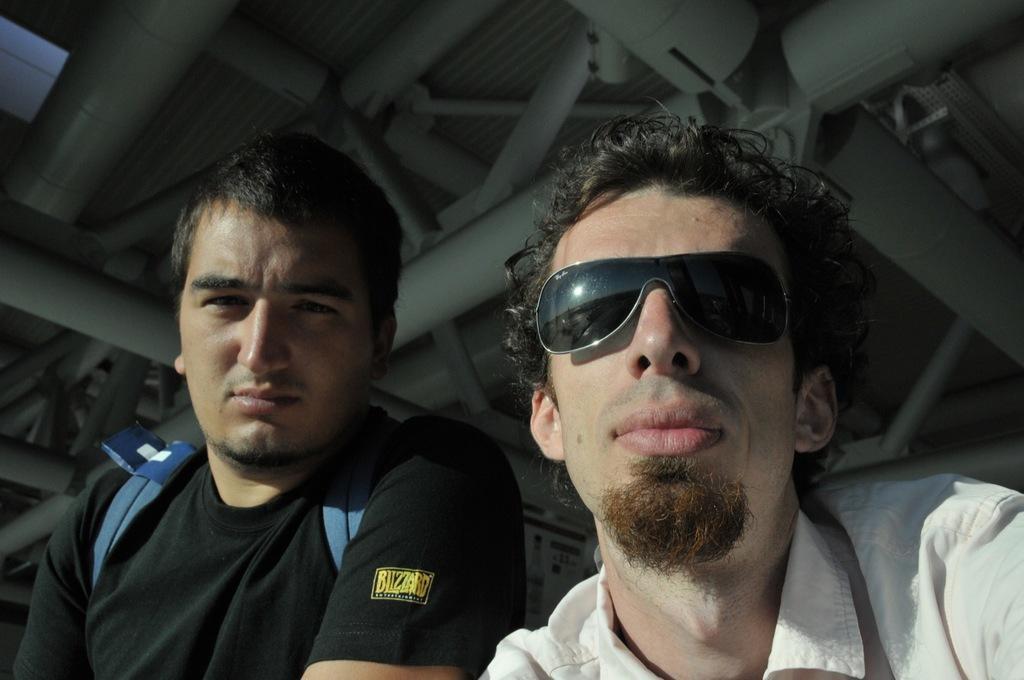How would you summarize this image in a sentence or two? In this image there are two men towards the bottom of the image, there is a man wearing a bag, there is a man wearing goggles, there is a roof towards the top of the image, there are pipes. 